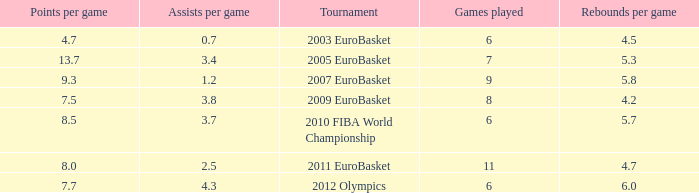How may assists per game have 7.7 points per game? 4.3. 